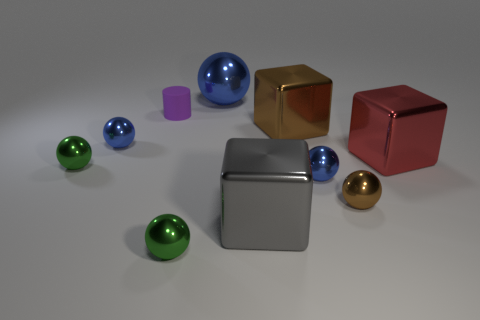There is a blue shiny object that is in front of the big red metallic thing behind the green metallic sphere on the left side of the small purple matte cylinder; what shape is it?
Your response must be concise. Sphere. What number of objects are either large shiny things that are behind the purple object or green spheres behind the brown ball?
Provide a short and direct response. 2. Are there any large brown metal cubes in front of the red shiny thing?
Your answer should be compact. No. What number of things are red metallic objects that are on the right side of the big brown object or blue metallic things?
Ensure brevity in your answer.  4. What number of cyan objects are large things or small metal things?
Ensure brevity in your answer.  0. What number of other things are the same color as the tiny cylinder?
Make the answer very short. 0. Is the number of green spheres on the right side of the big brown object less than the number of big red blocks?
Offer a very short reply. Yes. There is a tiny sphere to the left of the tiny blue sphere that is to the left of the green shiny object that is in front of the gray metal block; what color is it?
Offer a terse response. Green. Is there anything else that has the same material as the small purple cylinder?
Keep it short and to the point. No. There is a brown shiny thing that is the same shape as the red thing; what is its size?
Your response must be concise. Large. 